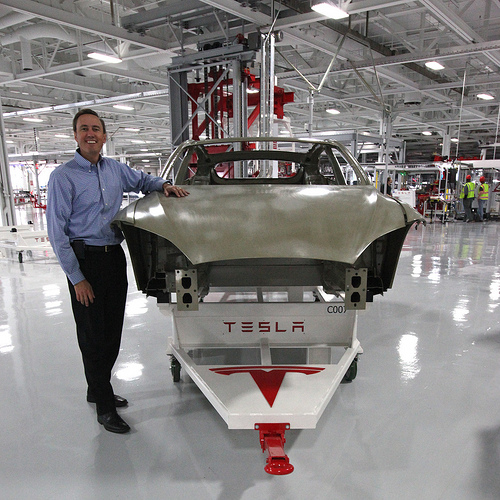<image>
Can you confirm if the man is to the right of the car? No. The man is not to the right of the car. The horizontal positioning shows a different relationship. 